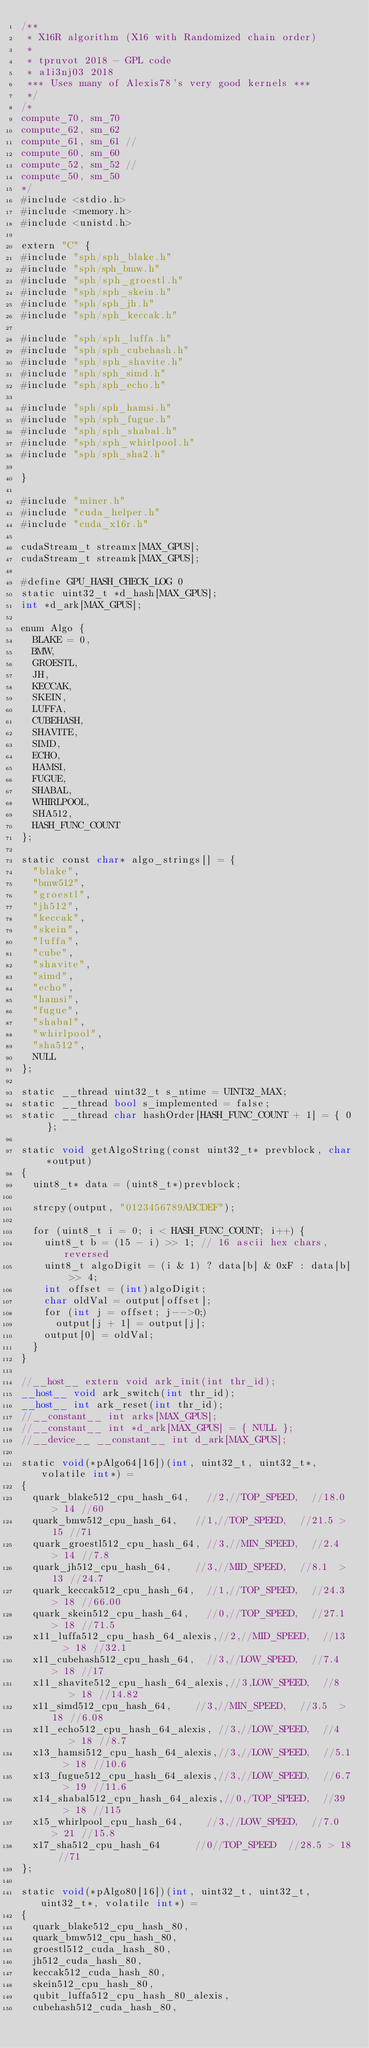<code> <loc_0><loc_0><loc_500><loc_500><_Cuda_>/**
 * X16R algorithm (X16 with Randomized chain order)
 *
 * tpruvot 2018 - GPL code
 * a1i3nj03 2018
 *** Uses many of Alexis78's very good kernels ***
 */
/*
compute_70, sm_70
compute_62, sm_62
compute_61, sm_61 //
compute_60, sm_60
compute_52, sm_52 //
compute_50, sm_50
*/
#include <stdio.h>
#include <memory.h>
#include <unistd.h>

extern "C" {
#include "sph/sph_blake.h"
#include "sph/sph_bmw.h"
#include "sph/sph_groestl.h"
#include "sph/sph_skein.h"
#include "sph/sph_jh.h"
#include "sph/sph_keccak.h"

#include "sph/sph_luffa.h"
#include "sph/sph_cubehash.h"
#include "sph/sph_shavite.h"
#include "sph/sph_simd.h"
#include "sph/sph_echo.h"

#include "sph/sph_hamsi.h"
#include "sph/sph_fugue.h"
#include "sph/sph_shabal.h"
#include "sph/sph_whirlpool.h"
#include "sph/sph_sha2.h"

}

#include "miner.h"
#include "cuda_helper.h"
#include "cuda_x16r.h"

cudaStream_t streamx[MAX_GPUS];
cudaStream_t streamk[MAX_GPUS];

#define GPU_HASH_CHECK_LOG 0
static uint32_t *d_hash[MAX_GPUS];
int *d_ark[MAX_GPUS];

enum Algo {
	BLAKE = 0,
	BMW,
	GROESTL,
	JH,
	KECCAK,
	SKEIN,
	LUFFA,
	CUBEHASH,
	SHAVITE,
	SIMD,
	ECHO,
	HAMSI,
	FUGUE,
	SHABAL,
	WHIRLPOOL,
	SHA512,
	HASH_FUNC_COUNT
};

static const char* algo_strings[] = {
	"blake",
	"bmw512",
	"groestl",
	"jh512",
	"keccak",
	"skein",
	"luffa",
	"cube",
	"shavite",
	"simd",
	"echo",
	"hamsi",
	"fugue",
	"shabal",
	"whirlpool",
	"sha512",
	NULL
};

static __thread uint32_t s_ntime = UINT32_MAX;
static __thread bool s_implemented = false;
static __thread char hashOrder[HASH_FUNC_COUNT + 1] = { 0 };

static void getAlgoString(const uint32_t* prevblock, char *output)
{
	uint8_t* data = (uint8_t*)prevblock;

	strcpy(output, "0123456789ABCDEF");

	for (uint8_t i = 0; i < HASH_FUNC_COUNT; i++) {
		uint8_t b = (15 - i) >> 1; // 16 ascii hex chars, reversed
		uint8_t algoDigit = (i & 1) ? data[b] & 0xF : data[b] >> 4;
		int offset = (int)algoDigit;
		char oldVal = output[offset];
		for (int j = offset; j-->0;)
			output[j + 1] = output[j];
		output[0] = oldVal;
	}
}

//__host__ extern void ark_init(int thr_id);
__host__ void ark_switch(int thr_id);
__host__ int ark_reset(int thr_id);
//__constant__ int arks[MAX_GPUS];
//__constant__ int *d_ark[MAX_GPUS] = { NULL };
//__device__ __constant__ int d_ark[MAX_GPUS];

static void(*pAlgo64[16])(int, uint32_t, uint32_t*, volatile int*) =
{
	quark_blake512_cpu_hash_64,		//2,//TOP_SPEED,	//18.0 > 14 //60
	quark_bmw512_cpu_hash_64,		//1,//TOP_SPEED,	//21.5 > 15 //71
	quark_groestl512_cpu_hash_64,	//3,//MIN_SPEED,	//2.4  > 14 //7.8
	quark_jh512_cpu_hash_64,		//3,//MID_SPEED,	//8.1  > 13 //24.7
	quark_keccak512_cpu_hash_64,	//1,//TOP_SPEED,	//24.3 > 18 //66.00
	quark_skein512_cpu_hash_64,		//0,//TOP_SPEED,	//27.1 > 18 //71.5
	x11_luffa512_cpu_hash_64_alexis,//2,//MID_SPEED,	//13   > 18 //32.1
	x11_cubehash512_cpu_hash_64,	//3,//LOW_SPEED,	//7.4  > 18 //17
	x11_shavite512_cpu_hash_64_alexis,//3,LOW_SPEED,	//8    > 18 //14.82
	x11_simd512_cpu_hash_64,		//3,//MIN_SPEED,	//3.5  > 18 //6.08
	x11_echo512_cpu_hash_64_alexis,	//3,//LOW_SPEED,	//4    > 18 //8.7
	x13_hamsi512_cpu_hash_64_alexis,//3,//LOW_SPEED,	//5.1  > 18 //10.6
	x13_fugue512_cpu_hash_64_alexis,//3,//LOW_SPEED,	//6.7  > 19 //11.6
	x14_shabal512_cpu_hash_64_alexis,//0,/TOP_SPEED,	//39   > 18 //115
	x15_whirlpool_cpu_hash_64,		//3,//LOW_SPEED,	//7.0  > 21 //15.8
	x17_sha512_cpu_hash_64			//0//TOP_SPEED	//28.5 > 18 //71
};

static void(*pAlgo80[16])(int, uint32_t, uint32_t, uint32_t*, volatile int*) =
{
	quark_blake512_cpu_hash_80,
	quark_bmw512_cpu_hash_80,
	groestl512_cuda_hash_80,
	jh512_cuda_hash_80,
	keccak512_cuda_hash_80,
	skein512_cpu_hash_80,
	qubit_luffa512_cpu_hash_80_alexis,
	cubehash512_cuda_hash_80,</code> 